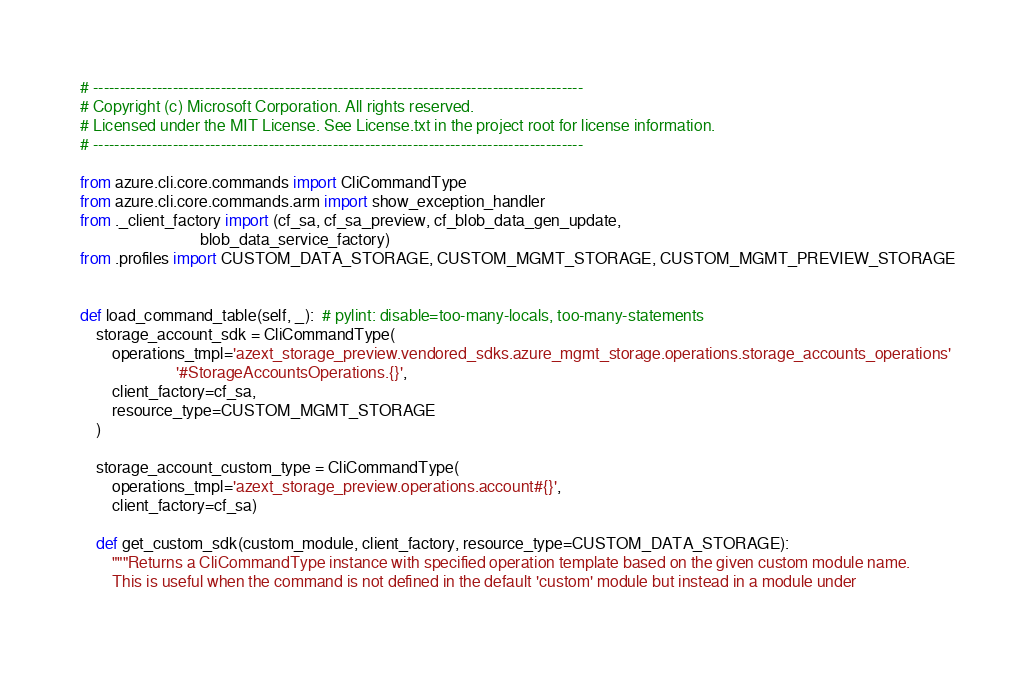Convert code to text. <code><loc_0><loc_0><loc_500><loc_500><_Python_># --------------------------------------------------------------------------------------------
# Copyright (c) Microsoft Corporation. All rights reserved.
# Licensed under the MIT License. See License.txt in the project root for license information.
# --------------------------------------------------------------------------------------------

from azure.cli.core.commands import CliCommandType
from azure.cli.core.commands.arm import show_exception_handler
from ._client_factory import (cf_sa, cf_sa_preview, cf_blob_data_gen_update,
                              blob_data_service_factory)
from .profiles import CUSTOM_DATA_STORAGE, CUSTOM_MGMT_STORAGE, CUSTOM_MGMT_PREVIEW_STORAGE


def load_command_table(self, _):  # pylint: disable=too-many-locals, too-many-statements
    storage_account_sdk = CliCommandType(
        operations_tmpl='azext_storage_preview.vendored_sdks.azure_mgmt_storage.operations.storage_accounts_operations'
                        '#StorageAccountsOperations.{}',
        client_factory=cf_sa,
        resource_type=CUSTOM_MGMT_STORAGE
    )

    storage_account_custom_type = CliCommandType(
        operations_tmpl='azext_storage_preview.operations.account#{}',
        client_factory=cf_sa)

    def get_custom_sdk(custom_module, client_factory, resource_type=CUSTOM_DATA_STORAGE):
        """Returns a CliCommandType instance with specified operation template based on the given custom module name.
        This is useful when the command is not defined in the default 'custom' module but instead in a module under</code> 